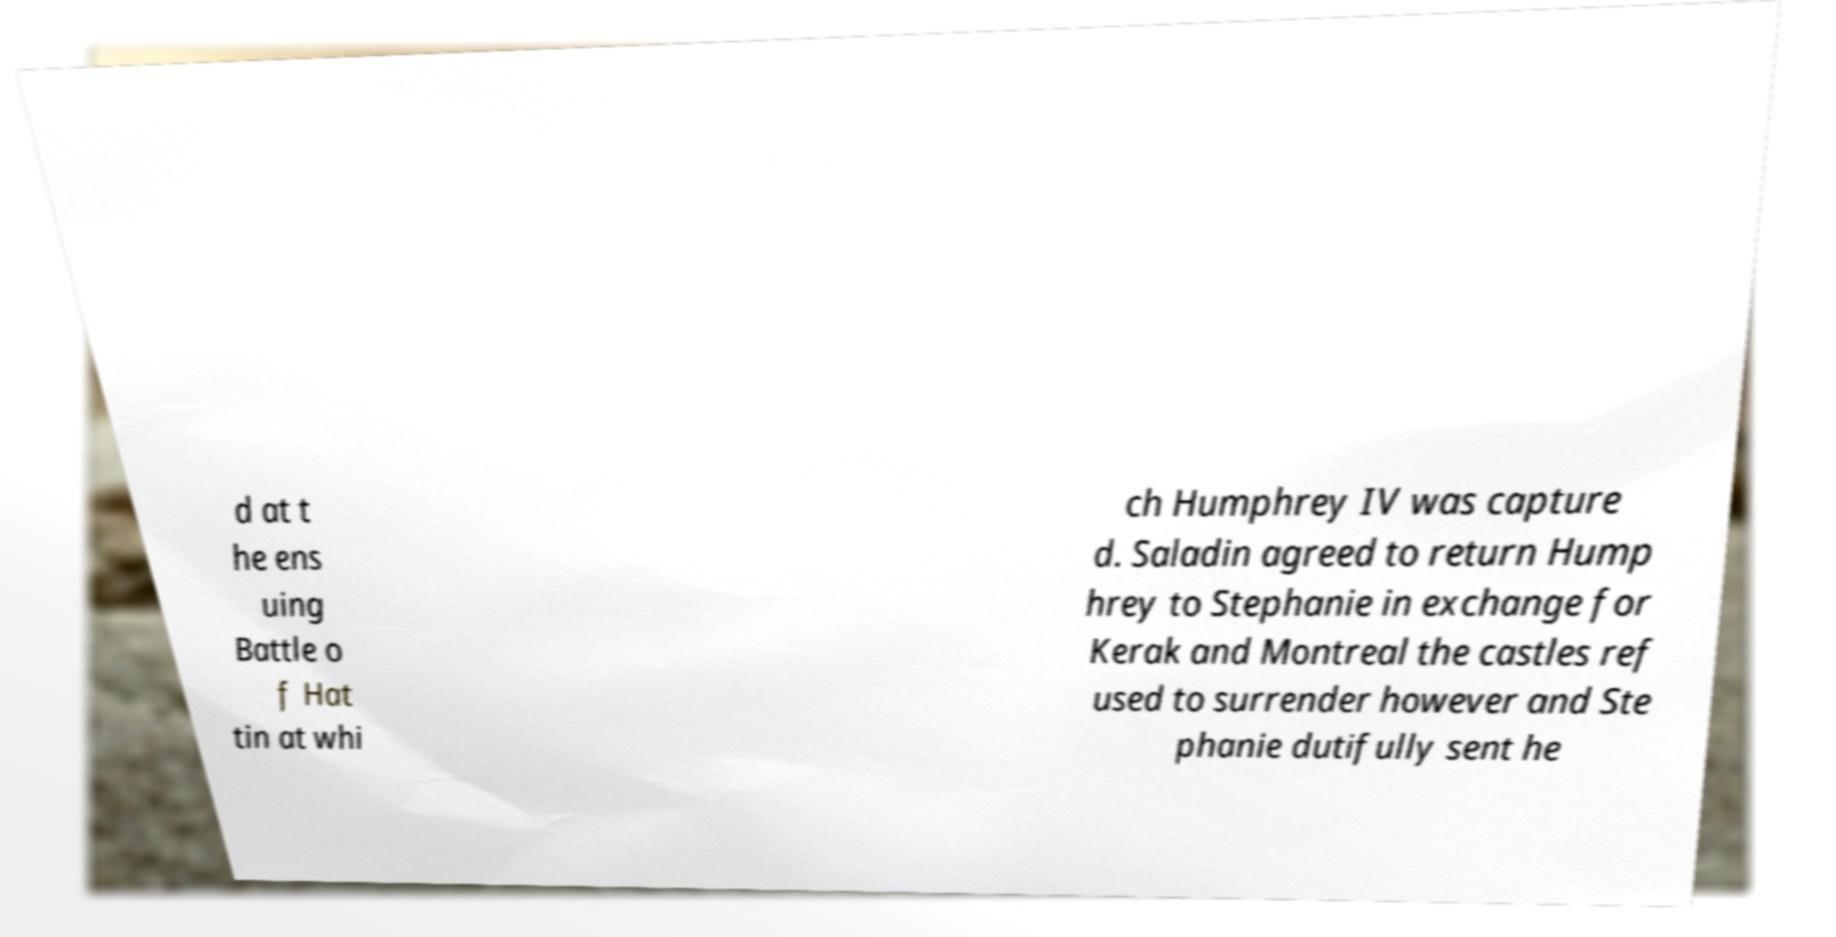Can you accurately transcribe the text from the provided image for me? d at t he ens uing Battle o f Hat tin at whi ch Humphrey IV was capture d. Saladin agreed to return Hump hrey to Stephanie in exchange for Kerak and Montreal the castles ref used to surrender however and Ste phanie dutifully sent he 